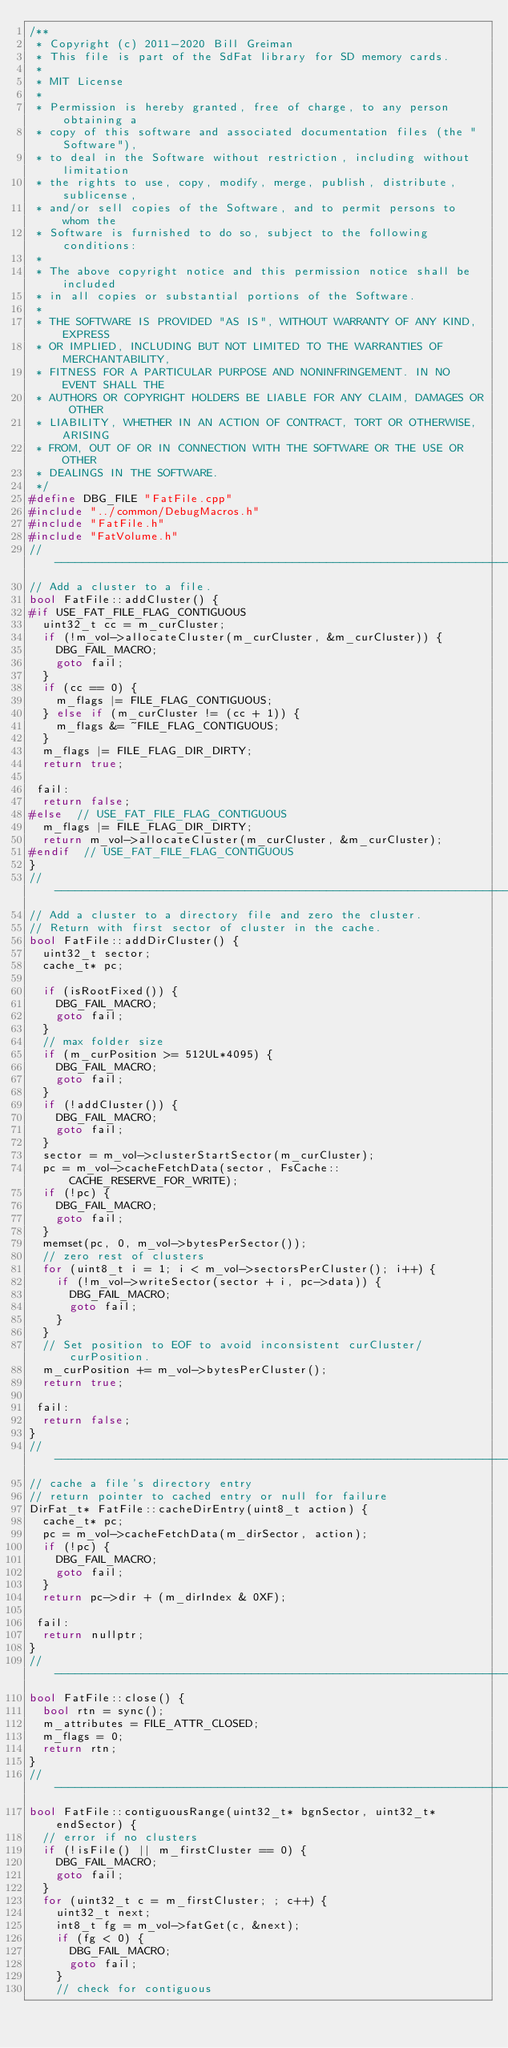<code> <loc_0><loc_0><loc_500><loc_500><_C++_>/**
 * Copyright (c) 2011-2020 Bill Greiman
 * This file is part of the SdFat library for SD memory cards.
 *
 * MIT License
 *
 * Permission is hereby granted, free of charge, to any person obtaining a
 * copy of this software and associated documentation files (the "Software"),
 * to deal in the Software without restriction, including without limitation
 * the rights to use, copy, modify, merge, publish, distribute, sublicense,
 * and/or sell copies of the Software, and to permit persons to whom the
 * Software is furnished to do so, subject to the following conditions:
 *
 * The above copyright notice and this permission notice shall be included
 * in all copies or substantial portions of the Software.
 *
 * THE SOFTWARE IS PROVIDED "AS IS", WITHOUT WARRANTY OF ANY KIND, EXPRESS
 * OR IMPLIED, INCLUDING BUT NOT LIMITED TO THE WARRANTIES OF MERCHANTABILITY,
 * FITNESS FOR A PARTICULAR PURPOSE AND NONINFRINGEMENT. IN NO EVENT SHALL THE
 * AUTHORS OR COPYRIGHT HOLDERS BE LIABLE FOR ANY CLAIM, DAMAGES OR OTHER
 * LIABILITY, WHETHER IN AN ACTION OF CONTRACT, TORT OR OTHERWISE, ARISING
 * FROM, OUT OF OR IN CONNECTION WITH THE SOFTWARE OR THE USE OR OTHER
 * DEALINGS IN THE SOFTWARE.
 */
#define DBG_FILE "FatFile.cpp"
#include "../common/DebugMacros.h"
#include "FatFile.h"
#include "FatVolume.h"
//------------------------------------------------------------------------------
// Add a cluster to a file.
bool FatFile::addCluster() {
#if USE_FAT_FILE_FLAG_CONTIGUOUS
  uint32_t cc = m_curCluster;
  if (!m_vol->allocateCluster(m_curCluster, &m_curCluster)) {
    DBG_FAIL_MACRO;
    goto fail;
  }
  if (cc == 0) {
    m_flags |= FILE_FLAG_CONTIGUOUS;
  } else if (m_curCluster != (cc + 1)) {
    m_flags &= ~FILE_FLAG_CONTIGUOUS;
  }
  m_flags |= FILE_FLAG_DIR_DIRTY;
  return true;

 fail:
  return false;
#else  // USE_FAT_FILE_FLAG_CONTIGUOUS
  m_flags |= FILE_FLAG_DIR_DIRTY;
  return m_vol->allocateCluster(m_curCluster, &m_curCluster);
#endif  // USE_FAT_FILE_FLAG_CONTIGUOUS
}
//------------------------------------------------------------------------------
// Add a cluster to a directory file and zero the cluster.
// Return with first sector of cluster in the cache.
bool FatFile::addDirCluster() {
  uint32_t sector;
  cache_t* pc;

  if (isRootFixed()) {
    DBG_FAIL_MACRO;
    goto fail;
  }
  // max folder size
  if (m_curPosition >= 512UL*4095) {
    DBG_FAIL_MACRO;
    goto fail;
  }
  if (!addCluster()) {
    DBG_FAIL_MACRO;
    goto fail;
  }
  sector = m_vol->clusterStartSector(m_curCluster);
  pc = m_vol->cacheFetchData(sector, FsCache::CACHE_RESERVE_FOR_WRITE);
  if (!pc) {
    DBG_FAIL_MACRO;
    goto fail;
  }
  memset(pc, 0, m_vol->bytesPerSector());
  // zero rest of clusters
  for (uint8_t i = 1; i < m_vol->sectorsPerCluster(); i++) {
    if (!m_vol->writeSector(sector + i, pc->data)) {
      DBG_FAIL_MACRO;
      goto fail;
    }
  }
  // Set position to EOF to avoid inconsistent curCluster/curPosition.
  m_curPosition += m_vol->bytesPerCluster();
  return true;

 fail:
  return false;
}
//------------------------------------------------------------------------------
// cache a file's directory entry
// return pointer to cached entry or null for failure
DirFat_t* FatFile::cacheDirEntry(uint8_t action) {
  cache_t* pc;
  pc = m_vol->cacheFetchData(m_dirSector, action);
  if (!pc) {
    DBG_FAIL_MACRO;
    goto fail;
  }
  return pc->dir + (m_dirIndex & 0XF);

 fail:
  return nullptr;
}
//------------------------------------------------------------------------------
bool FatFile::close() {
  bool rtn = sync();
  m_attributes = FILE_ATTR_CLOSED;
  m_flags = 0;
  return rtn;
}
//------------------------------------------------------------------------------
bool FatFile::contiguousRange(uint32_t* bgnSector, uint32_t* endSector) {
  // error if no clusters
  if (!isFile() || m_firstCluster == 0) {
    DBG_FAIL_MACRO;
    goto fail;
  }
  for (uint32_t c = m_firstCluster; ; c++) {
    uint32_t next;
    int8_t fg = m_vol->fatGet(c, &next);
    if (fg < 0) {
      DBG_FAIL_MACRO;
      goto fail;
    }
    // check for contiguous</code> 